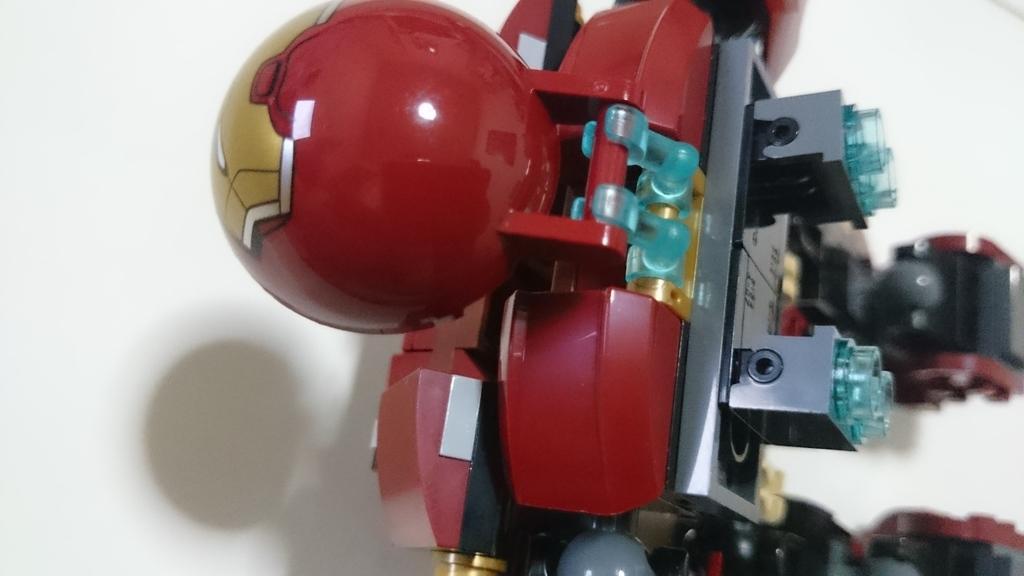Can you describe this image briefly? In this picture I can see there is a toy which is of red color and it is placed on a white surface. 